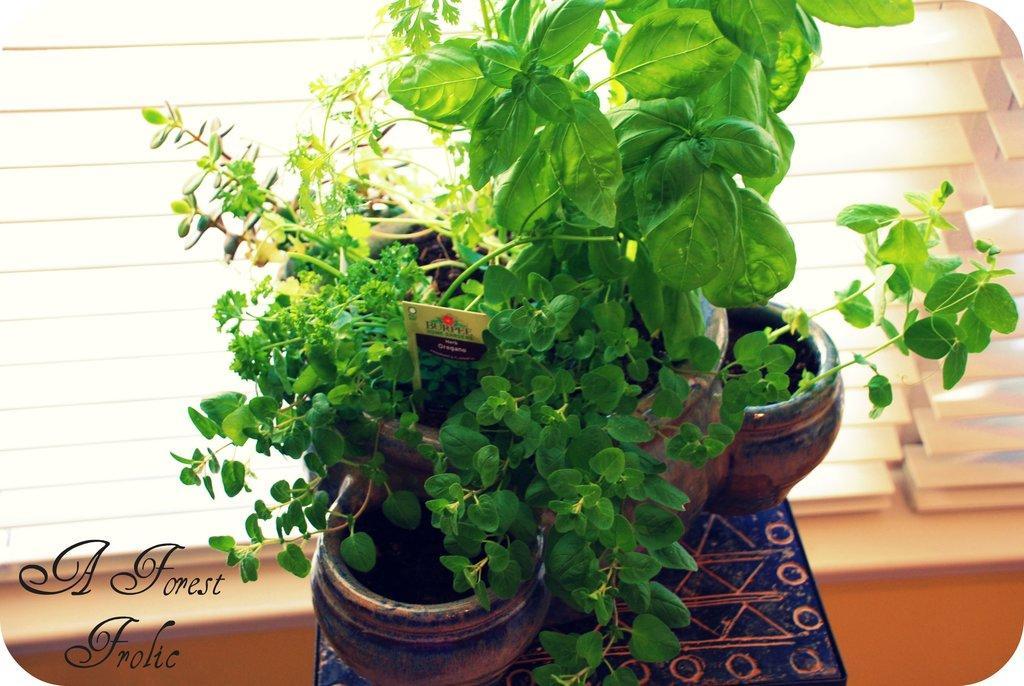Can you describe this image briefly? In this image there are few plant pots on the table, in front of them there is a window. At the bottom left side of the image there is some text. 